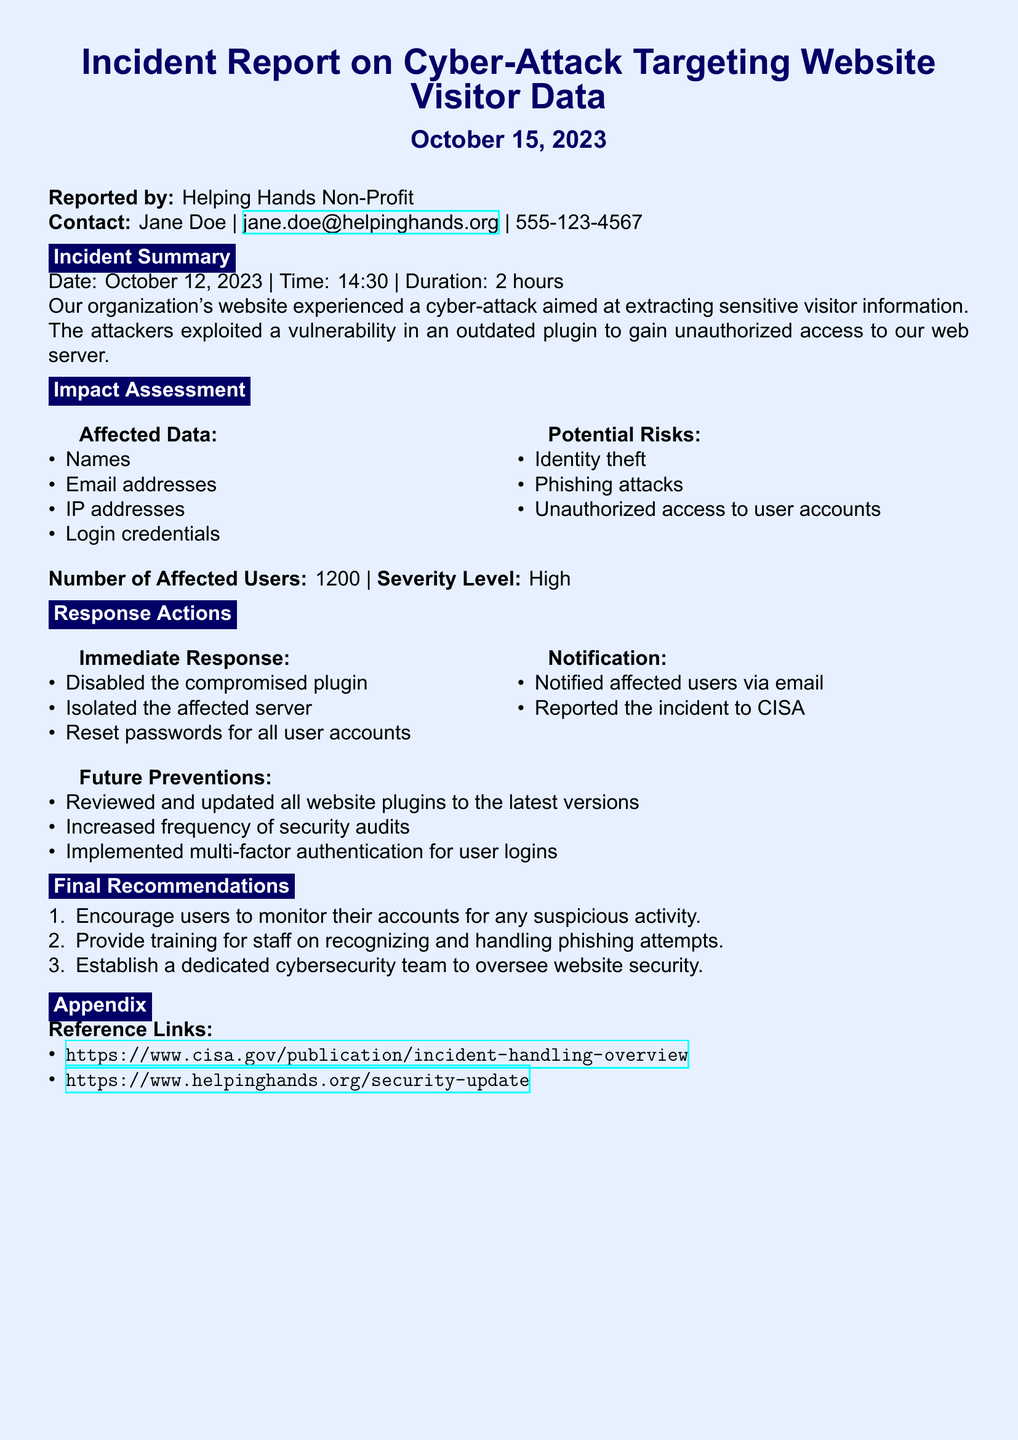What is the date of the incident? The incident occurred on October 12, 2023, as stated in the report.
Answer: October 12, 2023 How many users were affected by the attack? The document specifies that 1200 users were affected by the cyber-attack.
Answer: 1200 What was the severity level of the incident? The severity level is categorized as High in the impact assessment section of the report.
Answer: High What immediate action was taken to secure the website? The compromised plugin was disabled as part of the immediate response actions.
Answer: Disabled the compromised plugin What training is recommended for staff? The report suggests providing training for staff on recognizing and handling phishing attempts.
Answer: Recognizing and handling phishing attempts What type of authentication was implemented for user logins? The document states that multi-factor authentication was implemented to enhance security.
Answer: Multi-factor authentication What did the organization do with affected users? Affected users were notified via email as part of the response actions.
Answer: Notified via email Which agency was the incident reported to? The incident was reported to CISA, as mentioned in the notification section.
Answer: CISA 